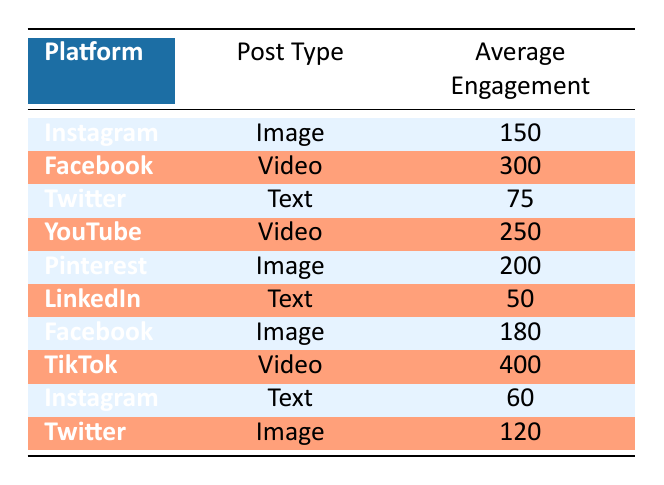What is the average engagement for video posts across platforms? The video posts in the table are from Facebook, YouTube, and TikTok with average engagements of 300, 250, and 400 respectively. To find the average, we sum these values: 300 + 250 + 400 = 950. Then, we divide by the number of video posts (3): 950 / 3 = 316.67, rounding gives us 317.
Answer: 317 Which platform has the highest average engagement for image posts? The image posts listed are from Instagram (150), Pinterest (200), and Facebook (180). The highest among these is from Pinterest with an average engagement of 200.
Answer: Pinterest Is the average engagement for text posts greater than 75? The text posts in the table are from Twitter (75), LinkedIn (50), and Instagram (60). The average engagements show that only Twitter meets the value of 75, while both LinkedIn and Instagram have lower values. Therefore, the statement is false.
Answer: No What is the total average engagement from all platforms for image posts? The average engagements for image posts are from Instagram (150), Pinterest (200), and Facebook (180). First, we sum these values: 150 + 200 + 180 = 530. Since there are 3 image posts, we do not need to find an average; we simply need the total, which is 530.
Answer: 530 Which type of post has the lowest average engagement overall? Looking at the table, we see the average engagements for text posts are Twitter (75), LinkedIn (50), and Instagram (60). The lowest value is from LinkedIn at 50. Comparing it to image (150, 200, 180) and video (300, 250, 400), neither of those types falls below 50, confirming text as the lowest engagement type.
Answer: Text 